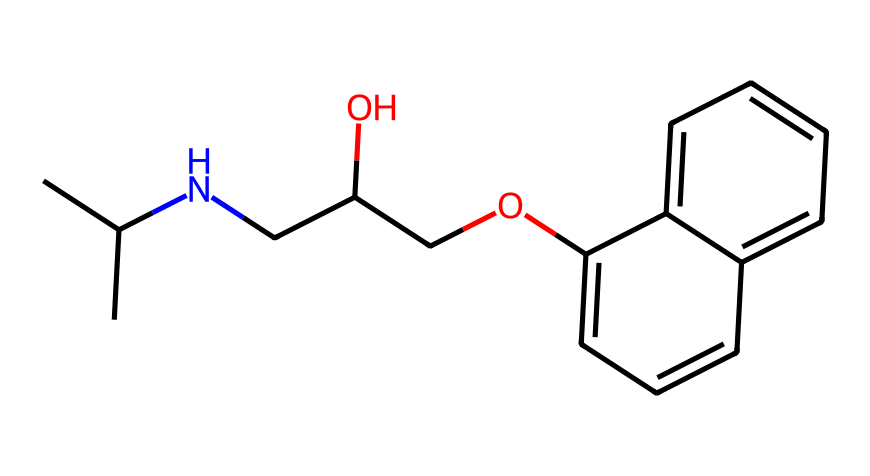How many carbon atoms are in propranolol? To find the number of carbon atoms, count each 'C' in the SMILES representation and remember that each group of 'CC' and those attached in the chain increase the count. The total is 17.
Answer: 17 What type of functional group is present in propranolol? Looking at the SMILES, the presence of the 'O' connected to a carbon (CC(O)) indicates an alcohol group (-OH). Since it's bonded to the carbon chain, it's identified as an alcohol.
Answer: alcohol How many nitrogen atoms are present in the structure? The SMILES includes one 'N', indicating the presence of a single nitrogen atom in propranolol.
Answer: 1 What is the overall molecular formula of propranolol? By combining the counted atoms from the SMILES representation (C, H, O, N), we derive the molecular formula: C16H21NO2. Count carefully as hydrogens are usually omitted in SMILES.
Answer: C16H21NO2 What kind of compound is propranolol classified as? The presence of beta-phenylethanolamine structure in the SMILES indicates that propranolol is classified as a beta-blocker, which is a subset of medicinal compounds that can affect heart rate.
Answer: beta-blocker What does the ‘COc’ section in the SMILES suggest about propranolol? The 'COc' indicates an ether functional group linking an alcohol part (O connected to C). This suggests propranolol has an ether linkage, which contributes to its solubility characteristics in organic and biological systems.
Answer: ether 